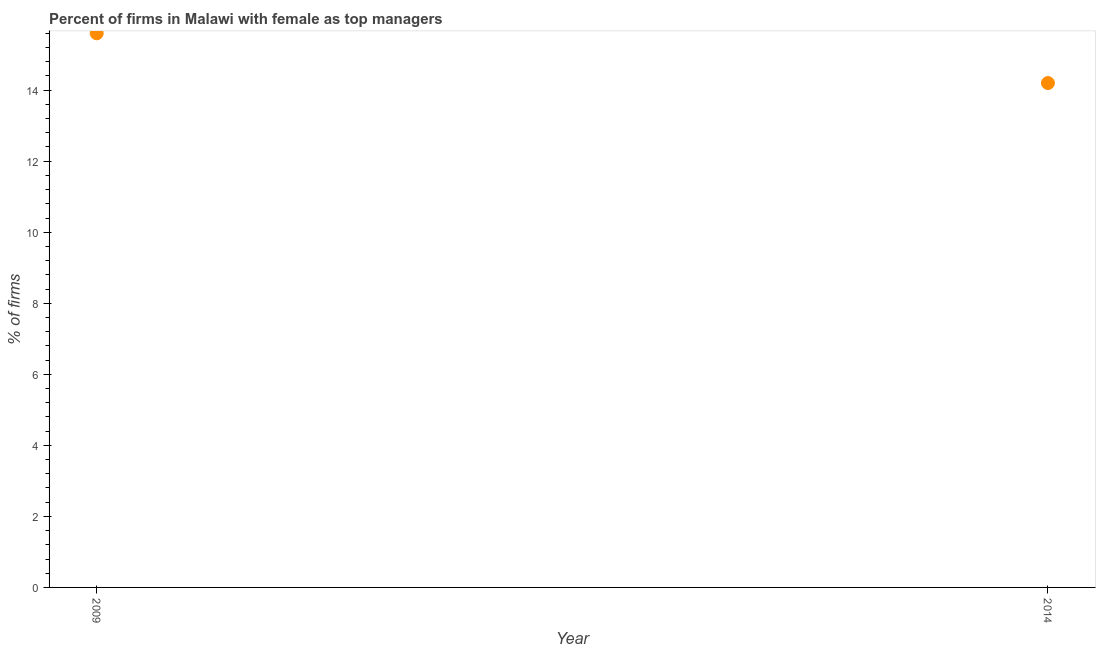Across all years, what is the maximum percentage of firms with female as top manager?
Offer a very short reply. 15.6. Across all years, what is the minimum percentage of firms with female as top manager?
Give a very brief answer. 14.2. What is the sum of the percentage of firms with female as top manager?
Provide a short and direct response. 29.8. What is the difference between the percentage of firms with female as top manager in 2009 and 2014?
Provide a succinct answer. 1.4. What is the average percentage of firms with female as top manager per year?
Provide a succinct answer. 14.9. What is the median percentage of firms with female as top manager?
Ensure brevity in your answer.  14.9. In how many years, is the percentage of firms with female as top manager greater than 1.2000000000000002 %?
Make the answer very short. 2. Do a majority of the years between 2009 and 2014 (inclusive) have percentage of firms with female as top manager greater than 9.6 %?
Provide a succinct answer. Yes. What is the ratio of the percentage of firms with female as top manager in 2009 to that in 2014?
Your response must be concise. 1.1. Is the percentage of firms with female as top manager in 2009 less than that in 2014?
Offer a very short reply. No. In how many years, is the percentage of firms with female as top manager greater than the average percentage of firms with female as top manager taken over all years?
Your response must be concise. 1. Does the percentage of firms with female as top manager monotonically increase over the years?
Your answer should be compact. No. How many dotlines are there?
Keep it short and to the point. 1. Does the graph contain grids?
Give a very brief answer. No. What is the title of the graph?
Give a very brief answer. Percent of firms in Malawi with female as top managers. What is the label or title of the Y-axis?
Your answer should be very brief. % of firms. What is the ratio of the % of firms in 2009 to that in 2014?
Ensure brevity in your answer.  1.1. 